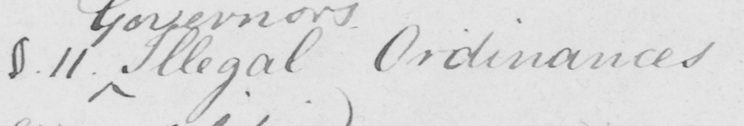Can you read and transcribe this handwriting? §.11 . Illegal Ordinances 